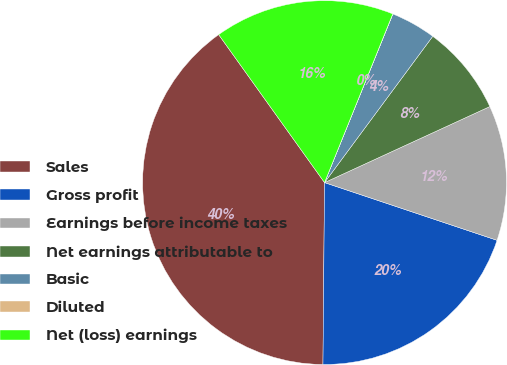<chart> <loc_0><loc_0><loc_500><loc_500><pie_chart><fcel>Sales<fcel>Gross profit<fcel>Earnings before income taxes<fcel>Net earnings attributable to<fcel>Basic<fcel>Diluted<fcel>Net (loss) earnings<nl><fcel>39.98%<fcel>20.0%<fcel>12.0%<fcel>8.0%<fcel>4.01%<fcel>0.01%<fcel>16.0%<nl></chart> 